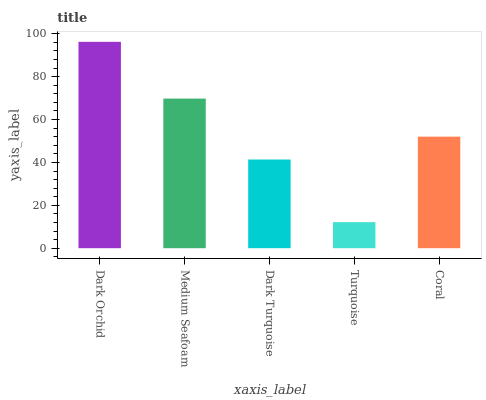Is Medium Seafoam the minimum?
Answer yes or no. No. Is Medium Seafoam the maximum?
Answer yes or no. No. Is Dark Orchid greater than Medium Seafoam?
Answer yes or no. Yes. Is Medium Seafoam less than Dark Orchid?
Answer yes or no. Yes. Is Medium Seafoam greater than Dark Orchid?
Answer yes or no. No. Is Dark Orchid less than Medium Seafoam?
Answer yes or no. No. Is Coral the high median?
Answer yes or no. Yes. Is Coral the low median?
Answer yes or no. Yes. Is Turquoise the high median?
Answer yes or no. No. Is Turquoise the low median?
Answer yes or no. No. 